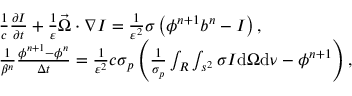Convert formula to latex. <formula><loc_0><loc_0><loc_500><loc_500>\begin{array} { r l } & { \frac { 1 } { c } \frac { \partial I } { \partial t } + \frac { 1 } { \varepsilon } \vec { \Omega } \cdot \nabla I = \frac { 1 } { \varepsilon ^ { 2 } } \sigma \left ( \phi ^ { n + 1 } b ^ { n } - I \right ) , } \\ & { \frac { 1 } { \beta ^ { n } } \frac { \phi ^ { n + 1 } - \phi ^ { n } } { \Delta t } = \frac { 1 } { \varepsilon ^ { 2 } } c \sigma _ { p } \left ( \frac { 1 } { \sigma _ { p } } \int _ { R } \int _ { s ^ { 2 } } \sigma I d \Omega d \nu - \phi ^ { n + 1 } \right ) , } \end{array}</formula> 